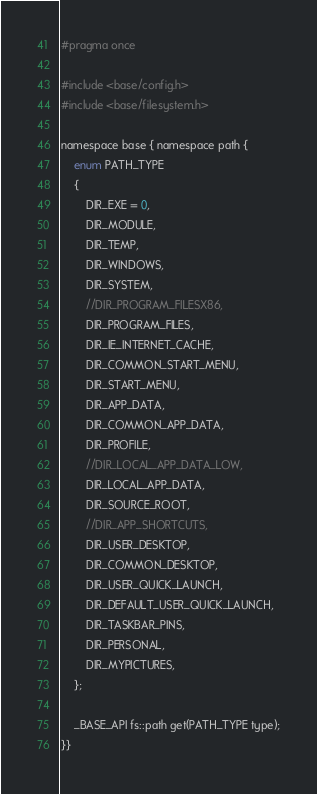Convert code to text. <code><loc_0><loc_0><loc_500><loc_500><_C_>#pragma once

#include <base/config.h>	   	  		
#include <base/filesystem.h>

namespace base { namespace path {
	enum PATH_TYPE
	{
		DIR_EXE = 0,
		DIR_MODULE,
		DIR_TEMP,
		DIR_WINDOWS,
		DIR_SYSTEM,
		//DIR_PROGRAM_FILESX86,
		DIR_PROGRAM_FILES,
		DIR_IE_INTERNET_CACHE,
		DIR_COMMON_START_MENU,
		DIR_START_MENU,
		DIR_APP_DATA,
		DIR_COMMON_APP_DATA,
		DIR_PROFILE,
		//DIR_LOCAL_APP_DATA_LOW,
		DIR_LOCAL_APP_DATA,
		DIR_SOURCE_ROOT, 
		//DIR_APP_SHORTCUTS, 
		DIR_USER_DESKTOP,
		DIR_COMMON_DESKTOP,
		DIR_USER_QUICK_LAUNCH,
		DIR_DEFAULT_USER_QUICK_LAUNCH,
		DIR_TASKBAR_PINS,
		DIR_PERSONAL,
		DIR_MYPICTURES,
	};

	_BASE_API fs::path get(PATH_TYPE type);
}}
</code> 